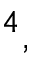Convert formula to latex. <formula><loc_0><loc_0><loc_500><loc_500>^ { 4 } ,</formula> 